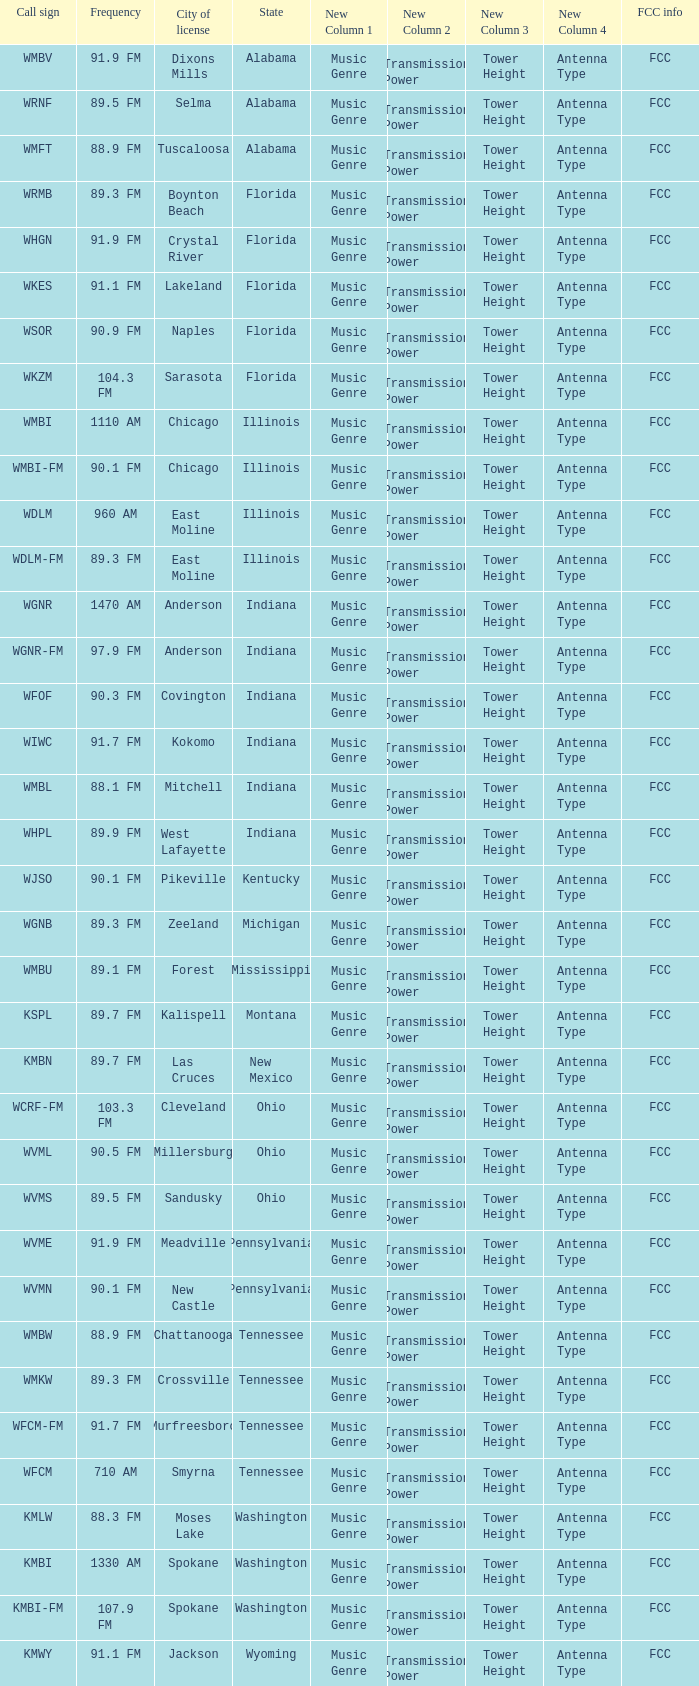Give me the full table as a dictionary. {'header': ['Call sign', 'Frequency', 'City of license', 'State', 'New Column 1', 'New Column 2', 'New Column 3', 'New Column 4', 'FCC info'], 'rows': [['WMBV', '91.9 FM', 'Dixons Mills', 'Alabama', 'Music Genre', 'Transmission Power', 'Tower Height', 'Antenna Type', 'FCC'], ['WRNF', '89.5 FM', 'Selma', 'Alabama', 'Music Genre', 'Transmission Power', 'Tower Height', 'Antenna Type', 'FCC'], ['WMFT', '88.9 FM', 'Tuscaloosa', 'Alabama', 'Music Genre', 'Transmission Power', 'Tower Height', 'Antenna Type', 'FCC'], ['WRMB', '89.3 FM', 'Boynton Beach', 'Florida', 'Music Genre', 'Transmission Power', 'Tower Height', 'Antenna Type', 'FCC'], ['WHGN', '91.9 FM', 'Crystal River', 'Florida', 'Music Genre', 'Transmission Power', 'Tower Height', 'Antenna Type', 'FCC'], ['WKES', '91.1 FM', 'Lakeland', 'Florida', 'Music Genre', 'Transmission Power', 'Tower Height', 'Antenna Type', 'FCC'], ['WSOR', '90.9 FM', 'Naples', 'Florida', 'Music Genre', 'Transmission Power', 'Tower Height', 'Antenna Type', 'FCC'], ['WKZM', '104.3 FM', 'Sarasota', 'Florida', 'Music Genre', 'Transmission Power', 'Tower Height', 'Antenna Type', 'FCC'], ['WMBI', '1110 AM', 'Chicago', 'Illinois', 'Music Genre', 'Transmission Power', 'Tower Height', 'Antenna Type', 'FCC'], ['WMBI-FM', '90.1 FM', 'Chicago', 'Illinois', 'Music Genre', 'Transmission Power', 'Tower Height', 'Antenna Type', 'FCC'], ['WDLM', '960 AM', 'East Moline', 'Illinois', 'Music Genre', 'Transmission Power', 'Tower Height', 'Antenna Type', 'FCC'], ['WDLM-FM', '89.3 FM', 'East Moline', 'Illinois', 'Music Genre', 'Transmission Power', 'Tower Height', 'Antenna Type', 'FCC'], ['WGNR', '1470 AM', 'Anderson', 'Indiana', 'Music Genre', 'Transmission Power', 'Tower Height', 'Antenna Type', 'FCC'], ['WGNR-FM', '97.9 FM', 'Anderson', 'Indiana', 'Music Genre', 'Transmission Power', 'Tower Height', 'Antenna Type', 'FCC'], ['WFOF', '90.3 FM', 'Covington', 'Indiana', 'Music Genre', 'Transmission Power', 'Tower Height', 'Antenna Type', 'FCC'], ['WIWC', '91.7 FM', 'Kokomo', 'Indiana', 'Music Genre', 'Transmission Power', 'Tower Height', 'Antenna Type', 'FCC'], ['WMBL', '88.1 FM', 'Mitchell', 'Indiana', 'Music Genre', 'Transmission Power', 'Tower Height', 'Antenna Type', 'FCC'], ['WHPL', '89.9 FM', 'West Lafayette', 'Indiana', 'Music Genre', 'Transmission Power', 'Tower Height', 'Antenna Type', 'FCC'], ['WJSO', '90.1 FM', 'Pikeville', 'Kentucky', 'Music Genre', 'Transmission Power', 'Tower Height', 'Antenna Type', 'FCC'], ['WGNB', '89.3 FM', 'Zeeland', 'Michigan', 'Music Genre', 'Transmission Power', 'Tower Height', 'Antenna Type', 'FCC'], ['WMBU', '89.1 FM', 'Forest', 'Mississippi', 'Music Genre', 'Transmission Power', 'Tower Height', 'Antenna Type', 'FCC'], ['KSPL', '89.7 FM', 'Kalispell', 'Montana', 'Music Genre', 'Transmission Power', 'Tower Height', 'Antenna Type', 'FCC'], ['KMBN', '89.7 FM', 'Las Cruces', 'New Mexico', 'Music Genre', 'Transmission Power', 'Tower Height', 'Antenna Type', 'FCC'], ['WCRF-FM', '103.3 FM', 'Cleveland', 'Ohio', 'Music Genre', 'Transmission Power', 'Tower Height', 'Antenna Type', 'FCC'], ['WVML', '90.5 FM', 'Millersburg', 'Ohio', 'Music Genre', 'Transmission Power', 'Tower Height', 'Antenna Type', 'FCC'], ['WVMS', '89.5 FM', 'Sandusky', 'Ohio', 'Music Genre', 'Transmission Power', 'Tower Height', 'Antenna Type', 'FCC'], ['WVME', '91.9 FM', 'Meadville', 'Pennsylvania', 'Music Genre', 'Transmission Power', 'Tower Height', 'Antenna Type', 'FCC'], ['WVMN', '90.1 FM', 'New Castle', 'Pennsylvania', 'Music Genre', 'Transmission Power', 'Tower Height', 'Antenna Type', 'FCC'], ['WMBW', '88.9 FM', 'Chattanooga', 'Tennessee', 'Music Genre', 'Transmission Power', 'Tower Height', 'Antenna Type', 'FCC'], ['WMKW', '89.3 FM', 'Crossville', 'Tennessee', 'Music Genre', 'Transmission Power', 'Tower Height', 'Antenna Type', 'FCC'], ['WFCM-FM', '91.7 FM', 'Murfreesboro', 'Tennessee', 'Music Genre', 'Transmission Power', 'Tower Height', 'Antenna Type', 'FCC'], ['WFCM', '710 AM', 'Smyrna', 'Tennessee', 'Music Genre', 'Transmission Power', 'Tower Height', 'Antenna Type', 'FCC'], ['KMLW', '88.3 FM', 'Moses Lake', 'Washington', 'Music Genre', 'Transmission Power', 'Tower Height', 'Antenna Type', 'FCC'], ['KMBI', '1330 AM', 'Spokane', 'Washington', 'Music Genre', 'Transmission Power', 'Tower Height', 'Antenna Type', 'FCC'], ['KMBI-FM', '107.9 FM', 'Spokane', 'Washington', 'Music Genre', 'Transmission Power', 'Tower Height', 'Antenna Type', 'FCC'], ['KMWY', '91.1 FM', 'Jackson', 'Wyoming', 'Music Genre', 'Transmission Power', 'Tower Height', 'Antenna Type', 'FCC']]} What city is 103.3 FM licensed in? Cleveland. 